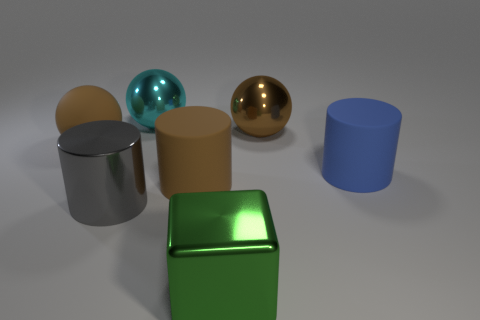Subtract all big metallic balls. How many balls are left? 1 Add 1 gray shiny cylinders. How many objects exist? 8 Subtract all brown cylinders. How many cylinders are left? 2 Subtract all cylinders. How many objects are left? 4 Subtract all green cylinders. How many brown balls are left? 2 Add 1 large brown rubber spheres. How many large brown rubber spheres exist? 2 Subtract 1 cyan spheres. How many objects are left? 6 Subtract 2 cylinders. How many cylinders are left? 1 Subtract all purple cylinders. Subtract all gray cubes. How many cylinders are left? 3 Subtract all large green shiny objects. Subtract all large cyan rubber cubes. How many objects are left? 6 